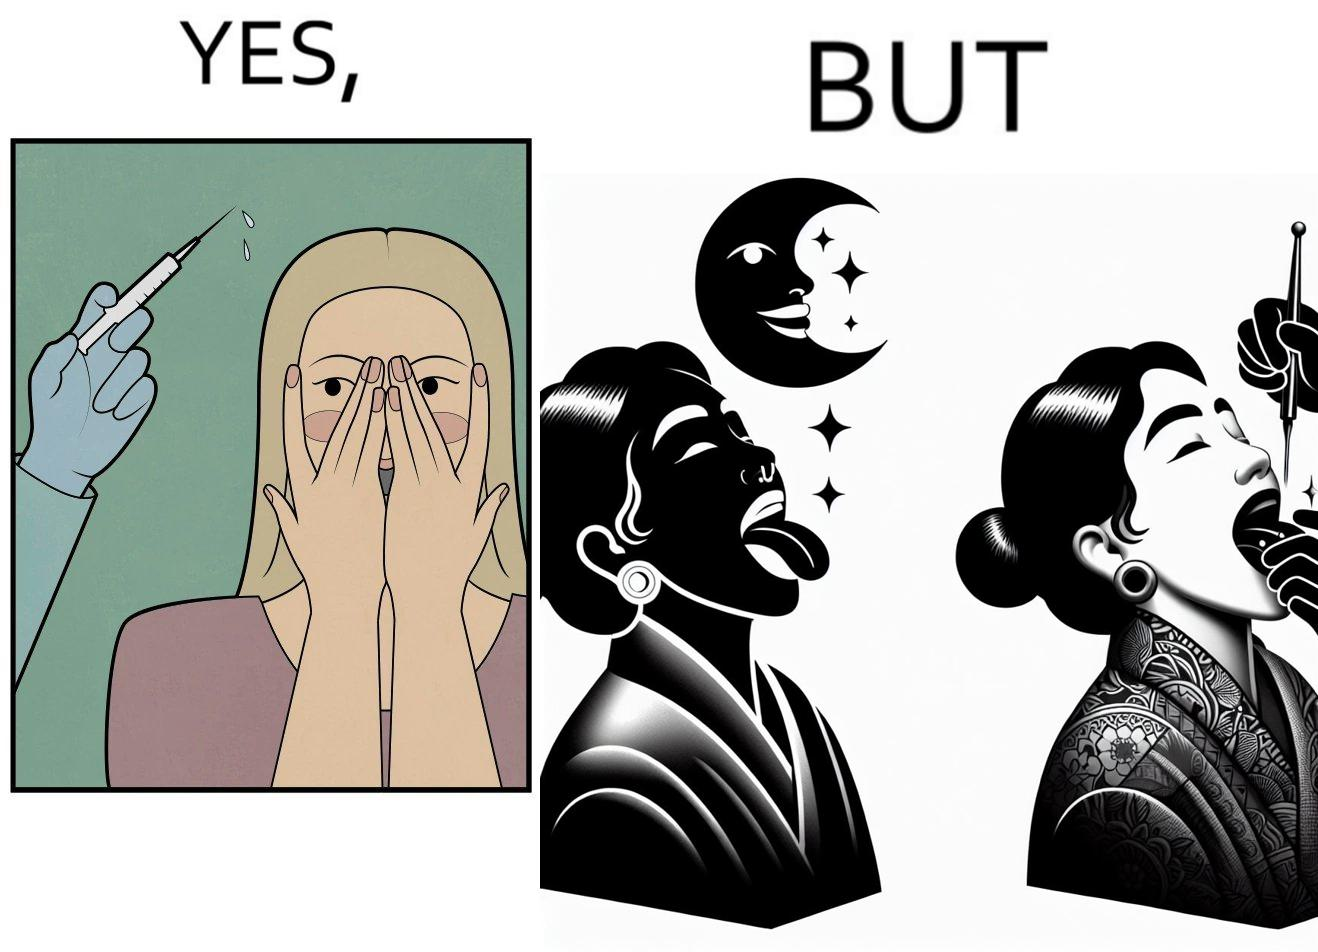What is shown in this image? The image is funny becuase while the woman is scared of getting an injection which is for her benefit, she is not afraid of getting a piercing or a tattoo which are not going to help her in any way. 